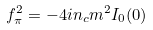<formula> <loc_0><loc_0><loc_500><loc_500>f ^ { 2 } _ { \pi } = - 4 i n _ { c } m ^ { 2 } I _ { 0 } ( 0 )</formula> 